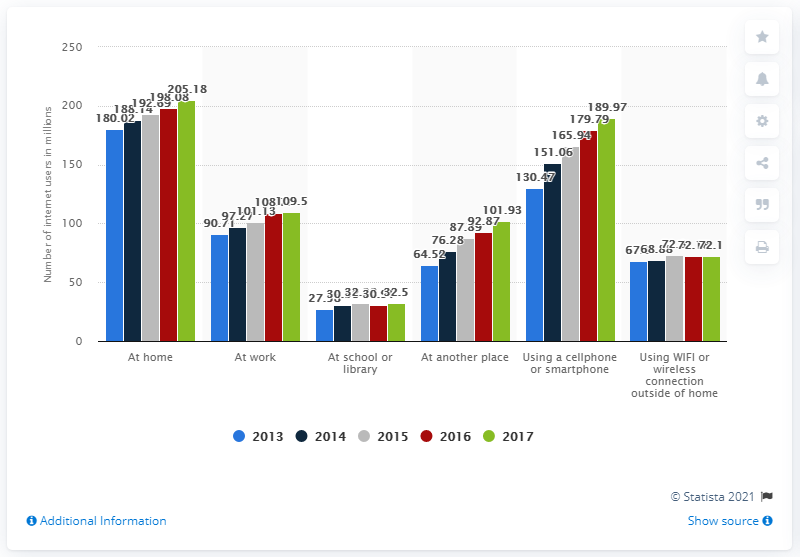Identify some key points in this picture. During the most recent survey period, 205.18% of U.S. adults had internet access at home. 